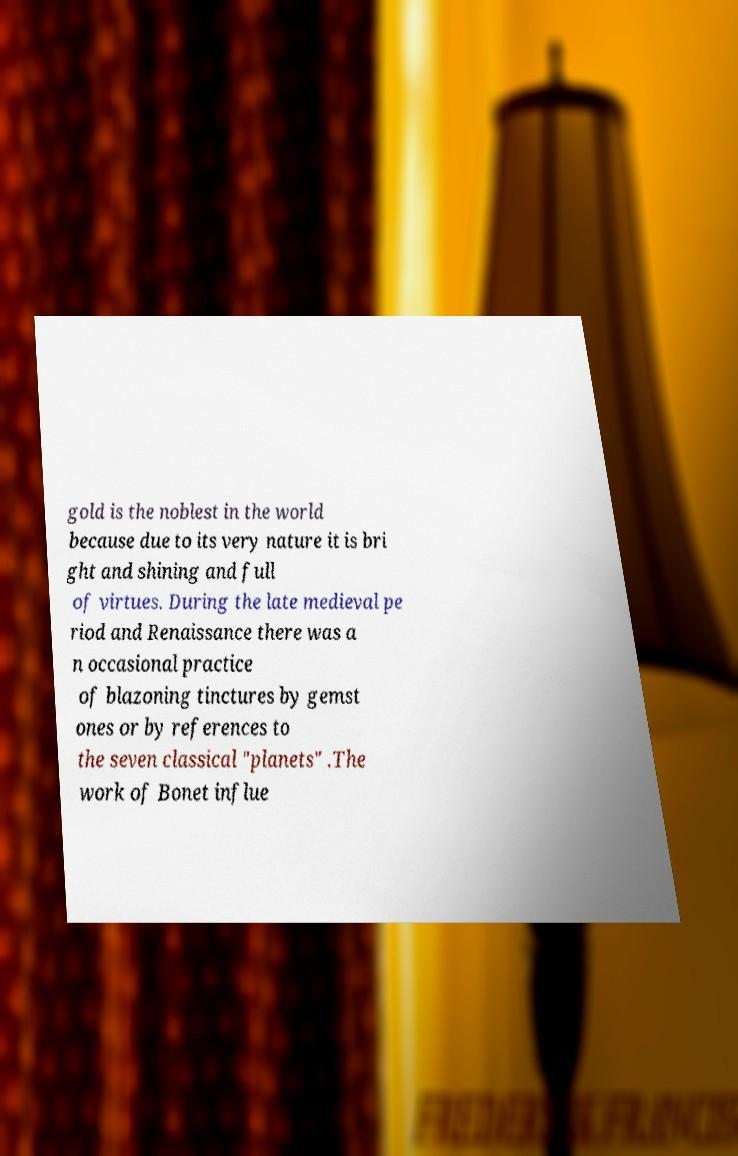Please identify and transcribe the text found in this image. gold is the noblest in the world because due to its very nature it is bri ght and shining and full of virtues. During the late medieval pe riod and Renaissance there was a n occasional practice of blazoning tinctures by gemst ones or by references to the seven classical "planets" .The work of Bonet influe 